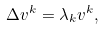Convert formula to latex. <formula><loc_0><loc_0><loc_500><loc_500>\Delta v ^ { k } = \lambda _ { k } v ^ { k } ,</formula> 